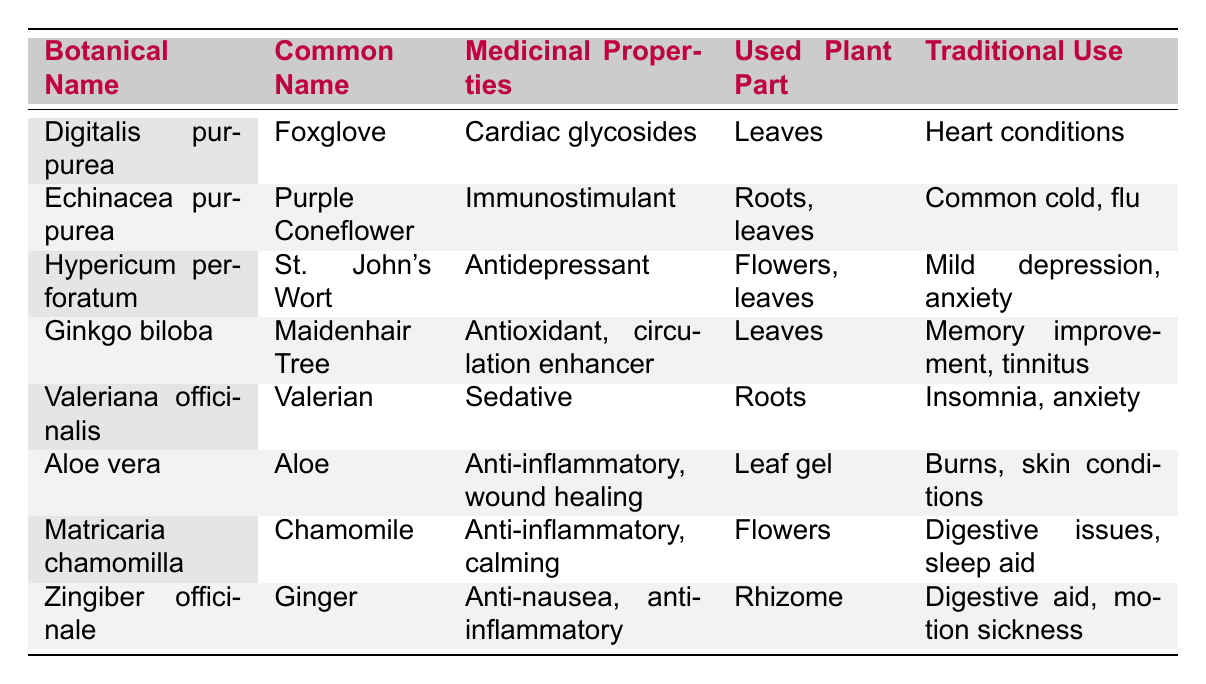What medicinal properties does Aloe vera have? The table lists Aloe vera under "Medicinal Properties" where it states its properties as "Anti-inflammatory, wound healing."
Answer: Anti-inflammatory, wound healing Which plant is commonly known as Foxglove? The table indicates that "Digitalis purpurea" is the botanical name for the common name "Foxglove."
Answer: Digitalis purpurea From which part of the plant is Ginger used? According to the table, Ginger, or "Zingiber officinale," uses the "Rhizome" as the used plant part.
Answer: Rhizome True or false: St. John's Wort is used for treating insomnia. The traditional use of "Hypericum perforatum" (St. John's Wort) listed in the table is "Mild depression, anxiety," which does not include insomnia treatment.
Answer: False Which plant has both anti-inflammatory and calming properties? Looking at the table, "Matricaria chamomilla" (Chamomile) is listed with "Anti-inflammatory, calming" as its medicinal properties.
Answer: Matricaria chamomilla If two plants are used for heart conditions, what are their common names? The table shows that "Digitalis purpurea" is used for heart conditions, but there are no other entries with the same use, thus only one answer is needed.
Answer: Foxglove What is the common use of Echinacea purpurea? The table states that the traditional use of "Echinacea purpurea" (Purple Coneflower) is for "Common cold, flu."
Answer: Common cold, flu Which used plant part is common for both Chamomile and Aloe? According to the table, "Chamomile" and "Aloe" both have flowers and leaf gel as their commonly used parts. However, since they're different, we note them separately. Thus there is no common part.
Answer: None What are the traditional uses of Ginkgo biloba? The table indicates that "Ginkgo biloba" is traditionally used for "Memory improvement, tinnitus."
Answer: Memory improvement, tinnitus Which plant is noted for having antidepressant properties and which parts are used? The table shows that "Hypericum perforatum" (St. John's Wort) is an antidepressant and uses "Flowers, leaves."
Answer: Hypericum perforatum; Flowers, leaves What is the average number of used plant parts across the listed plants? The table indicates various plant parts in numerical counts: 1 for leaves, 2 for roots/leaves, etc. The total counts are 12 used parts across 8 plants. So, averaging gives 12/8 = 1.5.
Answer: 1.5 